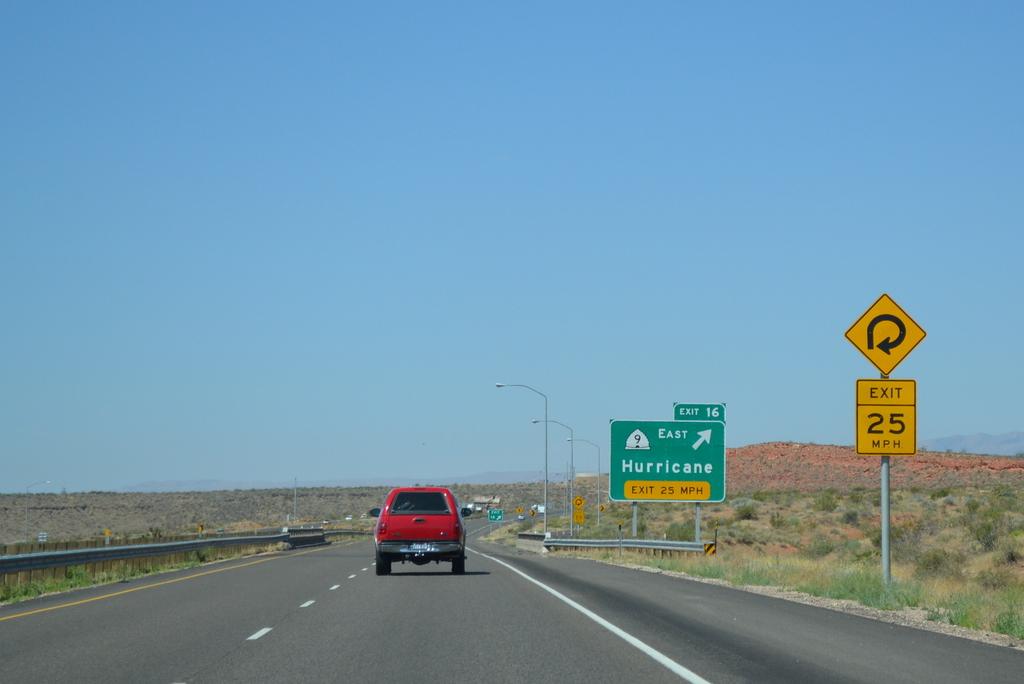Which town can be accessed by this exit?
Offer a very short reply. Hurricane. What is the suggested speed for the turn?
Ensure brevity in your answer.  25 mph. 